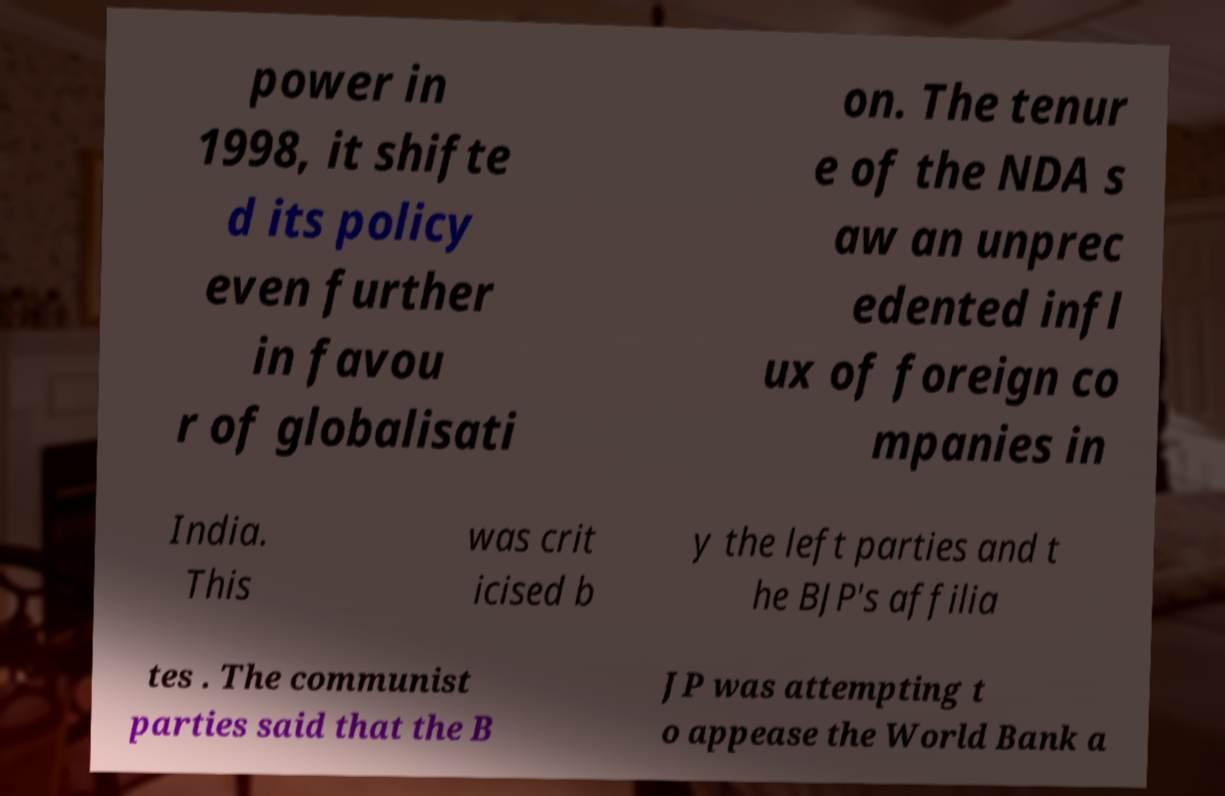There's text embedded in this image that I need extracted. Can you transcribe it verbatim? power in 1998, it shifte d its policy even further in favou r of globalisati on. The tenur e of the NDA s aw an unprec edented infl ux of foreign co mpanies in India. This was crit icised b y the left parties and t he BJP's affilia tes . The communist parties said that the B JP was attempting t o appease the World Bank a 